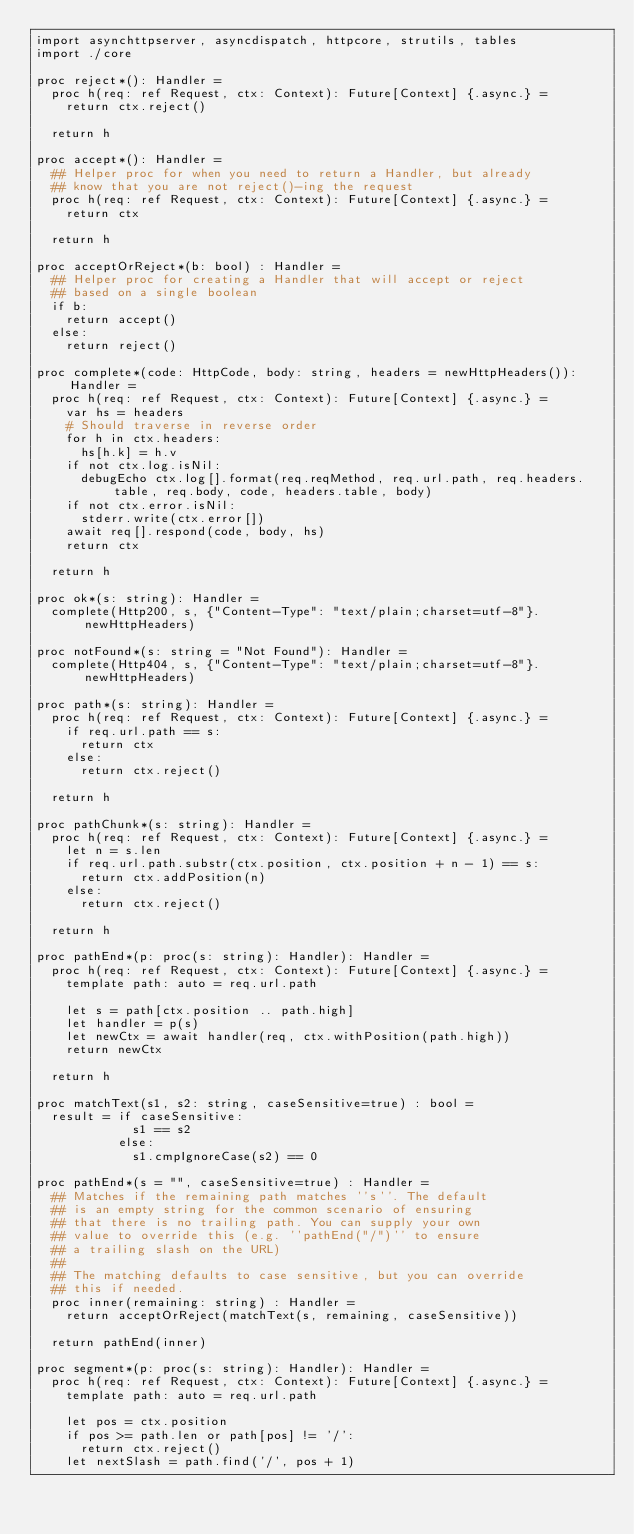<code> <loc_0><loc_0><loc_500><loc_500><_Nim_>import asynchttpserver, asyncdispatch, httpcore, strutils, tables
import ./core

proc reject*(): Handler =
  proc h(req: ref Request, ctx: Context): Future[Context] {.async.} =
    return ctx.reject()

  return h

proc accept*(): Handler =
  ## Helper proc for when you need to return a Handler, but already
  ## know that you are not reject()-ing the request
  proc h(req: ref Request, ctx: Context): Future[Context] {.async.} =
    return ctx

  return h

proc acceptOrReject*(b: bool) : Handler =
  ## Helper proc for creating a Handler that will accept or reject
  ## based on a single boolean
  if b:
    return accept()
  else:
    return reject()

proc complete*(code: HttpCode, body: string, headers = newHttpHeaders()): Handler =
  proc h(req: ref Request, ctx: Context): Future[Context] {.async.} =
    var hs = headers
    # Should traverse in reverse order
    for h in ctx.headers:
      hs[h.k] = h.v
    if not ctx.log.isNil:
      debugEcho ctx.log[].format(req.reqMethod, req.url.path, req.headers.table, req.body, code, headers.table, body)
    if not ctx.error.isNil:
      stderr.write(ctx.error[])
    await req[].respond(code, body, hs)
    return ctx

  return h

proc ok*(s: string): Handler =
  complete(Http200, s, {"Content-Type": "text/plain;charset=utf-8"}.newHttpHeaders)

proc notFound*(s: string = "Not Found"): Handler =
  complete(Http404, s, {"Content-Type": "text/plain;charset=utf-8"}.newHttpHeaders)

proc path*(s: string): Handler =
  proc h(req: ref Request, ctx: Context): Future[Context] {.async.} =
    if req.url.path == s:
      return ctx
    else:
      return ctx.reject()

  return h

proc pathChunk*(s: string): Handler =
  proc h(req: ref Request, ctx: Context): Future[Context] {.async.} =
    let n = s.len
    if req.url.path.substr(ctx.position, ctx.position + n - 1) == s:
      return ctx.addPosition(n)
    else:
      return ctx.reject()

  return h

proc pathEnd*(p: proc(s: string): Handler): Handler =
  proc h(req: ref Request, ctx: Context): Future[Context] {.async.} =
    template path: auto = req.url.path

    let s = path[ctx.position .. path.high]
    let handler = p(s)
    let newCtx = await handler(req, ctx.withPosition(path.high))
    return newCtx

  return h

proc matchText(s1, s2: string, caseSensitive=true) : bool =
  result = if caseSensitive:
             s1 == s2
           else:
             s1.cmpIgnoreCase(s2) == 0

proc pathEnd*(s = "", caseSensitive=true) : Handler =
  ## Matches if the remaining path matches ''s''. The default
  ## is an empty string for the common scenario of ensuring
  ## that there is no trailing path. You can supply your own
  ## value to override this (e.g. ''pathEnd("/")'' to ensure
  ## a trailing slash on the URL)
  ##
  ## The matching defaults to case sensitive, but you can override
  ## this if needed.
  proc inner(remaining: string) : Handler =
    return acceptOrReject(matchText(s, remaining, caseSensitive))

  return pathEnd(inner)

proc segment*(p: proc(s: string): Handler): Handler =
  proc h(req: ref Request, ctx: Context): Future[Context] {.async.} =
    template path: auto = req.url.path

    let pos = ctx.position
    if pos >= path.len or path[pos] != '/':
      return ctx.reject()
    let nextSlash = path.find('/', pos + 1)</code> 